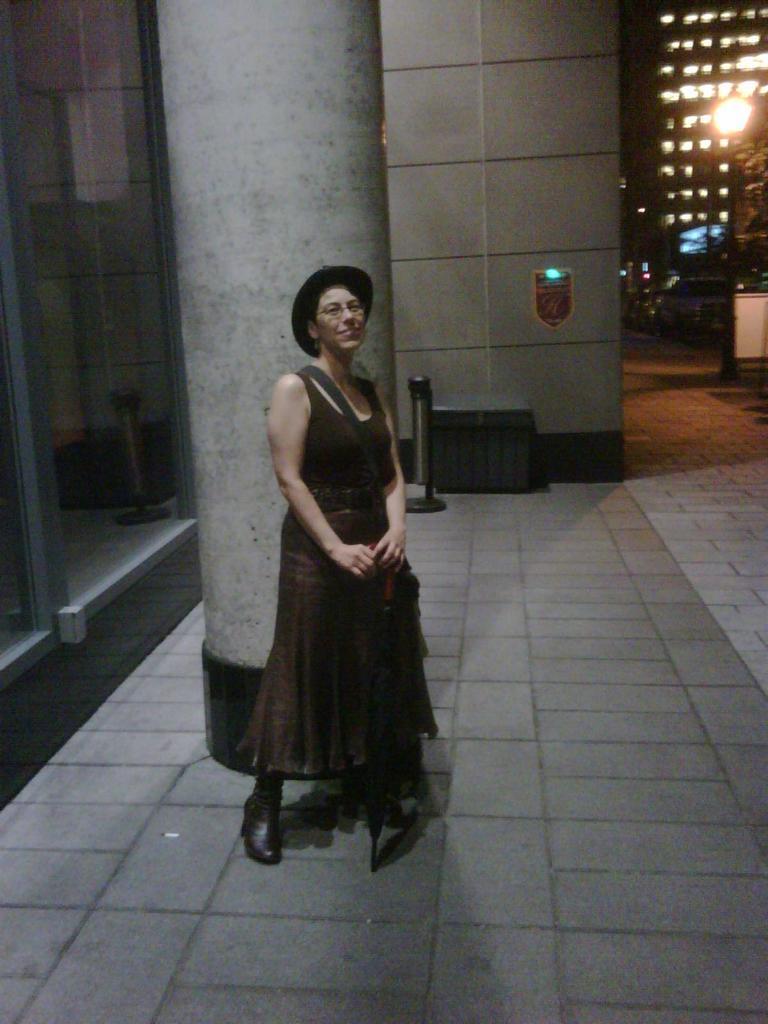Please provide a concise description of this image. This image consists of a woman wearing brown dress and a hat. At the bottom, there is a floor. Behind her there is a pillar. In the background, there are buildings. It looks like it is clicked outside. 